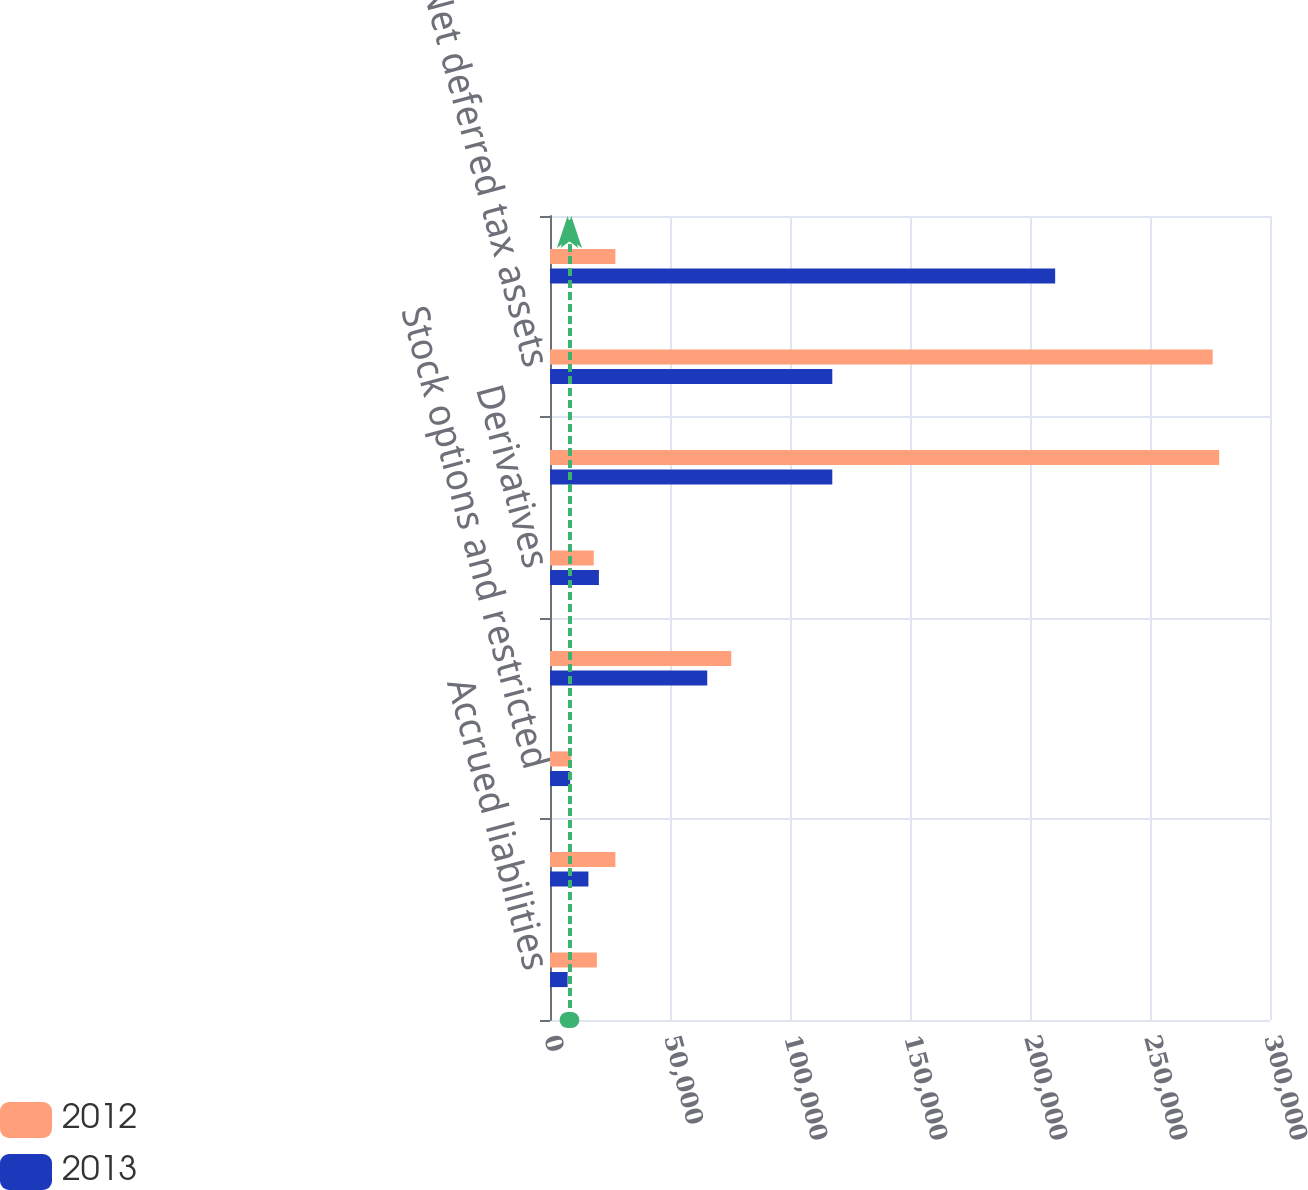Convert chart to OTSL. <chart><loc_0><loc_0><loc_500><loc_500><stacked_bar_chart><ecel><fcel>Accrued liabilities<fcel>Employee benefits and<fcel>Stock options and restricted<fcel>Pension and postretirement<fcel>Derivatives<fcel>Gross deferred tax assets<fcel>Net deferred tax assets<fcel>Property plant and equipment<nl><fcel>2012<fcel>19521<fcel>27252<fcel>8875<fcel>75518<fcel>18221<fcel>278835<fcel>276120<fcel>27252<nl><fcel>2013<fcel>7332<fcel>16002<fcel>8389<fcel>65520<fcel>20381<fcel>117624<fcel>117624<fcel>210486<nl></chart> 